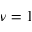<formula> <loc_0><loc_0><loc_500><loc_500>\nu = 1</formula> 